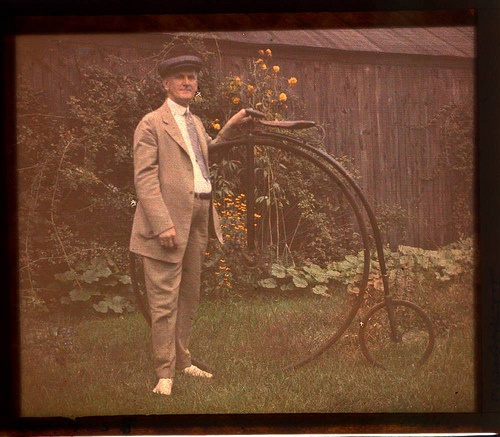Describe the objects in this image and their specific colors. I can see bicycle in black, brown, gray, and maroon tones, people in black, brown, salmon, and tan tones, and tie in black, salmon, and gray tones in this image. 